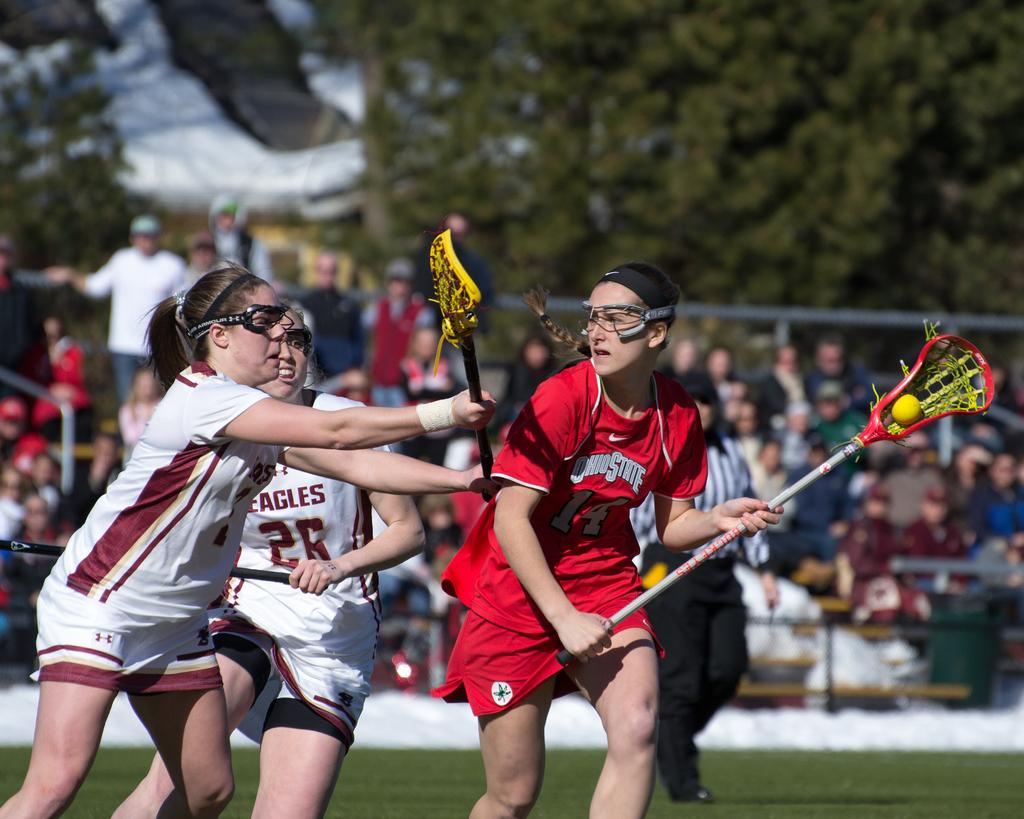<image>
Relay a brief, clear account of the picture shown. Several female athletes are playing on a field with one having the number 25 on her chest. 